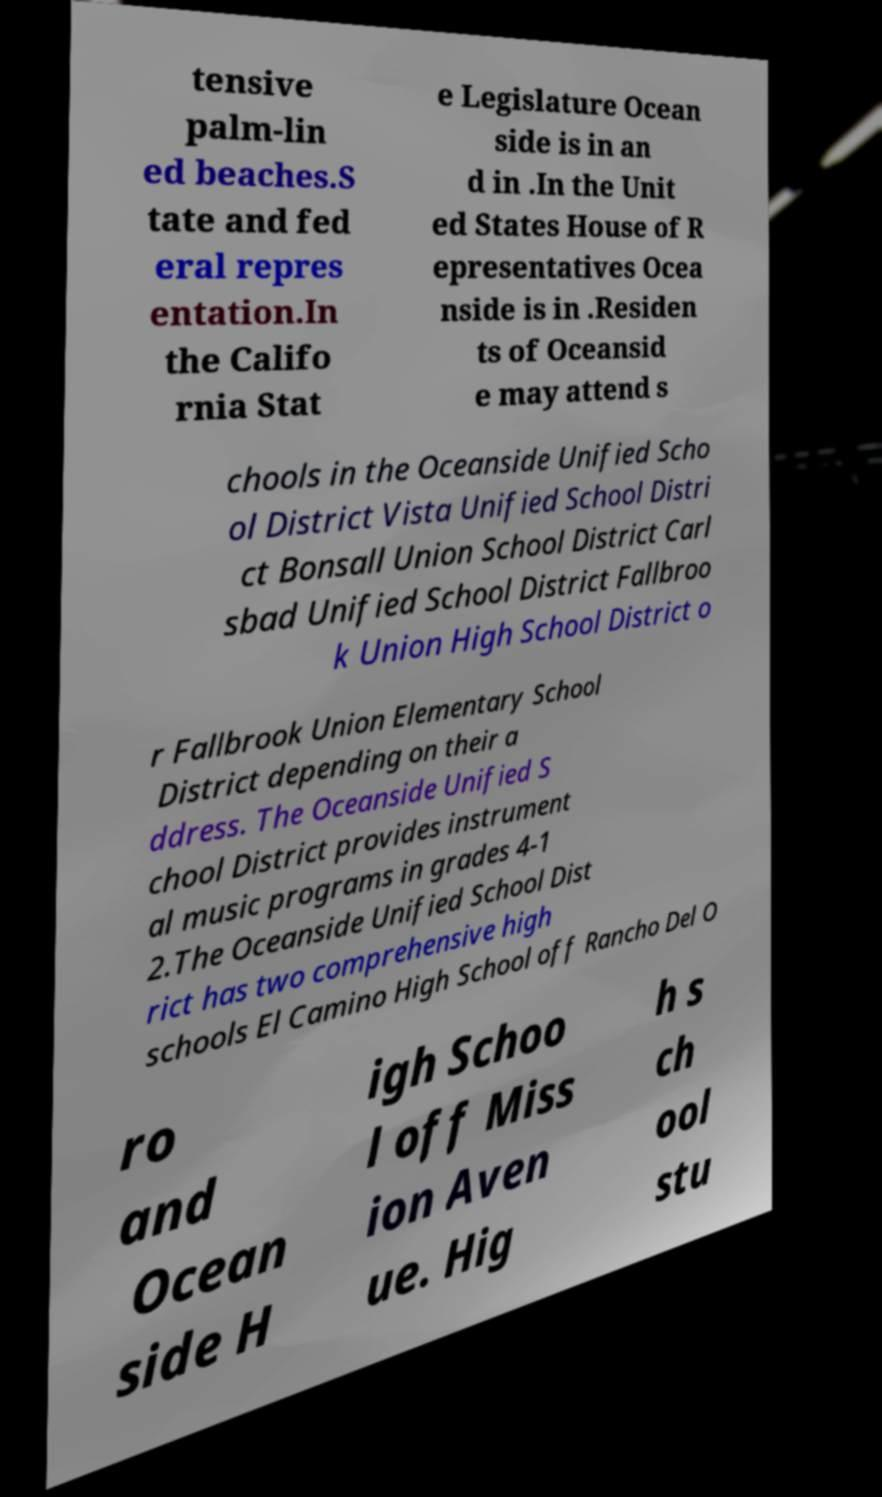Could you extract and type out the text from this image? tensive palm-lin ed beaches.S tate and fed eral repres entation.In the Califo rnia Stat e Legislature Ocean side is in an d in .In the Unit ed States House of R epresentatives Ocea nside is in .Residen ts of Oceansid e may attend s chools in the Oceanside Unified Scho ol District Vista Unified School Distri ct Bonsall Union School District Carl sbad Unified School District Fallbroo k Union High School District o r Fallbrook Union Elementary School District depending on their a ddress. The Oceanside Unified S chool District provides instrument al music programs in grades 4-1 2.The Oceanside Unified School Dist rict has two comprehensive high schools El Camino High School off Rancho Del O ro and Ocean side H igh Schoo l off Miss ion Aven ue. Hig h s ch ool stu 